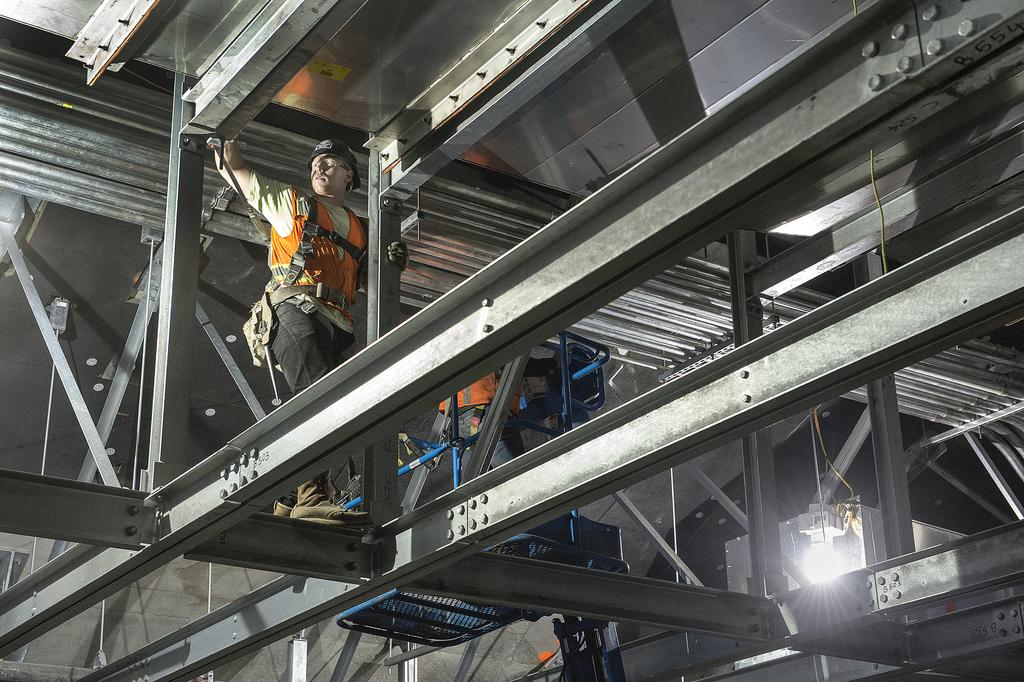What are the persons in the image doing? The persons in the image are standing on iron bars in the center of the image. What can be seen on the right side of the image? There is a light on the right side of the image. What is visible in the background of the image? There is a wall in the background of the image. What language are the kittens speaking in the image? There are no kittens present in the image, so it is not possible to determine what language they might be speaking. 